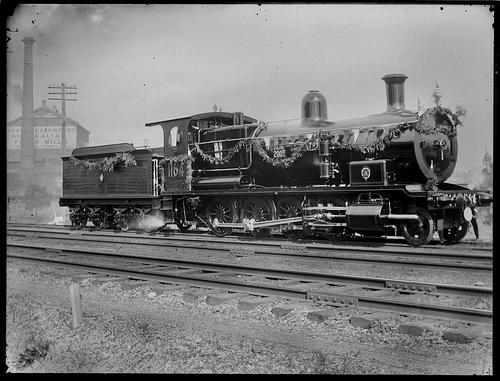What color is the train?
Answer briefly. Black. Is this a grainy photo or is their debris in the air?
Answer briefly. Debris. Is there graffiti on the train?
Keep it brief. No. Is the train moving?
Concise answer only. Yes. What powers this train?
Give a very brief answer. Coal. Is this the end of the track?
Keep it brief. No. What does this train use to propel it?
Short answer required. Steam. What letter on the train is closest to the viewer?
Give a very brief answer. Cur. Does this train have electronic components that assist its engineer?
Write a very short answer. No. Is this a big plane?
Keep it brief. No. 